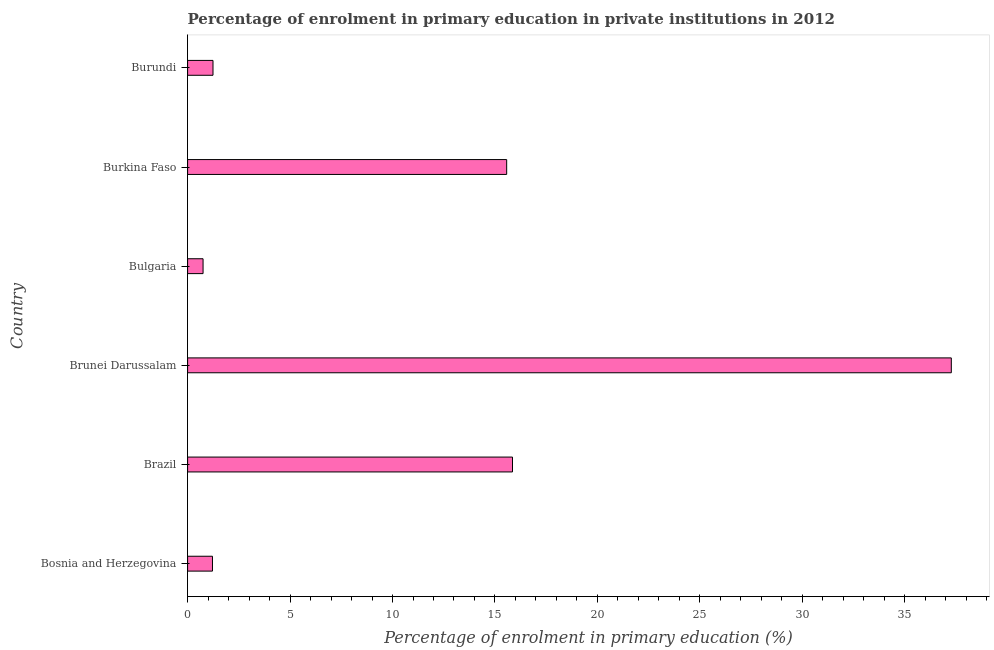Does the graph contain grids?
Provide a short and direct response. No. What is the title of the graph?
Ensure brevity in your answer.  Percentage of enrolment in primary education in private institutions in 2012. What is the label or title of the X-axis?
Offer a very short reply. Percentage of enrolment in primary education (%). What is the enrolment percentage in primary education in Bulgaria?
Provide a succinct answer. 0.75. Across all countries, what is the maximum enrolment percentage in primary education?
Provide a short and direct response. 37.27. Across all countries, what is the minimum enrolment percentage in primary education?
Offer a very short reply. 0.75. In which country was the enrolment percentage in primary education maximum?
Offer a terse response. Brunei Darussalam. In which country was the enrolment percentage in primary education minimum?
Provide a succinct answer. Bulgaria. What is the sum of the enrolment percentage in primary education?
Your answer should be compact. 71.9. What is the average enrolment percentage in primary education per country?
Your answer should be very brief. 11.98. What is the median enrolment percentage in primary education?
Ensure brevity in your answer.  8.41. What is the ratio of the enrolment percentage in primary education in Brazil to that in Bulgaria?
Keep it short and to the point. 21. Is the enrolment percentage in primary education in Brazil less than that in Burundi?
Offer a terse response. No. Is the difference between the enrolment percentage in primary education in Bulgaria and Burundi greater than the difference between any two countries?
Give a very brief answer. No. What is the difference between the highest and the second highest enrolment percentage in primary education?
Provide a short and direct response. 21.41. What is the difference between the highest and the lowest enrolment percentage in primary education?
Offer a very short reply. 36.52. How many bars are there?
Make the answer very short. 6. How many countries are there in the graph?
Offer a very short reply. 6. What is the difference between two consecutive major ticks on the X-axis?
Your answer should be compact. 5. What is the Percentage of enrolment in primary education (%) of Bosnia and Herzegovina?
Provide a succinct answer. 1.21. What is the Percentage of enrolment in primary education (%) of Brazil?
Offer a very short reply. 15.86. What is the Percentage of enrolment in primary education (%) of Brunei Darussalam?
Provide a succinct answer. 37.27. What is the Percentage of enrolment in primary education (%) of Bulgaria?
Give a very brief answer. 0.75. What is the Percentage of enrolment in primary education (%) of Burkina Faso?
Make the answer very short. 15.57. What is the Percentage of enrolment in primary education (%) in Burundi?
Offer a terse response. 1.24. What is the difference between the Percentage of enrolment in primary education (%) in Bosnia and Herzegovina and Brazil?
Keep it short and to the point. -14.64. What is the difference between the Percentage of enrolment in primary education (%) in Bosnia and Herzegovina and Brunei Darussalam?
Provide a succinct answer. -36.06. What is the difference between the Percentage of enrolment in primary education (%) in Bosnia and Herzegovina and Bulgaria?
Ensure brevity in your answer.  0.46. What is the difference between the Percentage of enrolment in primary education (%) in Bosnia and Herzegovina and Burkina Faso?
Your response must be concise. -14.36. What is the difference between the Percentage of enrolment in primary education (%) in Bosnia and Herzegovina and Burundi?
Make the answer very short. -0.03. What is the difference between the Percentage of enrolment in primary education (%) in Brazil and Brunei Darussalam?
Give a very brief answer. -21.41. What is the difference between the Percentage of enrolment in primary education (%) in Brazil and Bulgaria?
Your answer should be very brief. 15.1. What is the difference between the Percentage of enrolment in primary education (%) in Brazil and Burkina Faso?
Offer a terse response. 0.28. What is the difference between the Percentage of enrolment in primary education (%) in Brazil and Burundi?
Provide a short and direct response. 14.62. What is the difference between the Percentage of enrolment in primary education (%) in Brunei Darussalam and Bulgaria?
Give a very brief answer. 36.52. What is the difference between the Percentage of enrolment in primary education (%) in Brunei Darussalam and Burkina Faso?
Offer a terse response. 21.7. What is the difference between the Percentage of enrolment in primary education (%) in Brunei Darussalam and Burundi?
Your response must be concise. 36.03. What is the difference between the Percentage of enrolment in primary education (%) in Bulgaria and Burkina Faso?
Your answer should be compact. -14.82. What is the difference between the Percentage of enrolment in primary education (%) in Bulgaria and Burundi?
Ensure brevity in your answer.  -0.48. What is the difference between the Percentage of enrolment in primary education (%) in Burkina Faso and Burundi?
Give a very brief answer. 14.33. What is the ratio of the Percentage of enrolment in primary education (%) in Bosnia and Herzegovina to that in Brazil?
Make the answer very short. 0.08. What is the ratio of the Percentage of enrolment in primary education (%) in Bosnia and Herzegovina to that in Brunei Darussalam?
Ensure brevity in your answer.  0.03. What is the ratio of the Percentage of enrolment in primary education (%) in Bosnia and Herzegovina to that in Bulgaria?
Make the answer very short. 1.61. What is the ratio of the Percentage of enrolment in primary education (%) in Bosnia and Herzegovina to that in Burkina Faso?
Give a very brief answer. 0.08. What is the ratio of the Percentage of enrolment in primary education (%) in Brazil to that in Brunei Darussalam?
Offer a very short reply. 0.42. What is the ratio of the Percentage of enrolment in primary education (%) in Brazil to that in Bulgaria?
Make the answer very short. 21. What is the ratio of the Percentage of enrolment in primary education (%) in Brazil to that in Burkina Faso?
Your response must be concise. 1.02. What is the ratio of the Percentage of enrolment in primary education (%) in Brazil to that in Burundi?
Keep it short and to the point. 12.79. What is the ratio of the Percentage of enrolment in primary education (%) in Brunei Darussalam to that in Bulgaria?
Your answer should be compact. 49.38. What is the ratio of the Percentage of enrolment in primary education (%) in Brunei Darussalam to that in Burkina Faso?
Make the answer very short. 2.39. What is the ratio of the Percentage of enrolment in primary education (%) in Brunei Darussalam to that in Burundi?
Provide a succinct answer. 30.06. What is the ratio of the Percentage of enrolment in primary education (%) in Bulgaria to that in Burkina Faso?
Provide a short and direct response. 0.05. What is the ratio of the Percentage of enrolment in primary education (%) in Bulgaria to that in Burundi?
Keep it short and to the point. 0.61. What is the ratio of the Percentage of enrolment in primary education (%) in Burkina Faso to that in Burundi?
Your answer should be very brief. 12.56. 